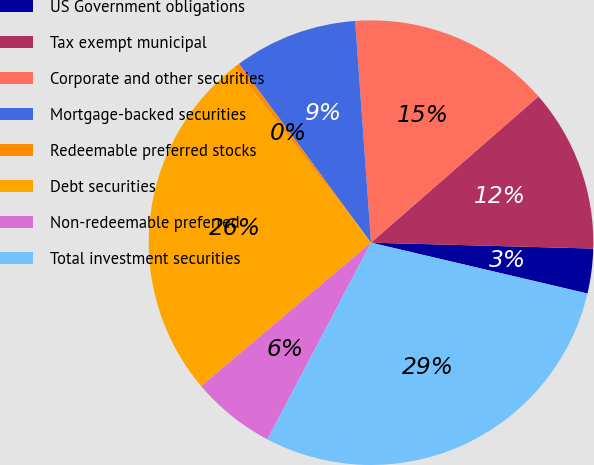Convert chart to OTSL. <chart><loc_0><loc_0><loc_500><loc_500><pie_chart><fcel>US Government obligations<fcel>Tax exempt municipal<fcel>Corporate and other securities<fcel>Mortgage-backed securities<fcel>Redeemable preferred stocks<fcel>Debt securities<fcel>Non-redeemable preferred<fcel>Total investment securities<nl><fcel>3.25%<fcel>11.85%<fcel>14.71%<fcel>8.98%<fcel>0.39%<fcel>25.65%<fcel>6.12%<fcel>29.04%<nl></chart> 